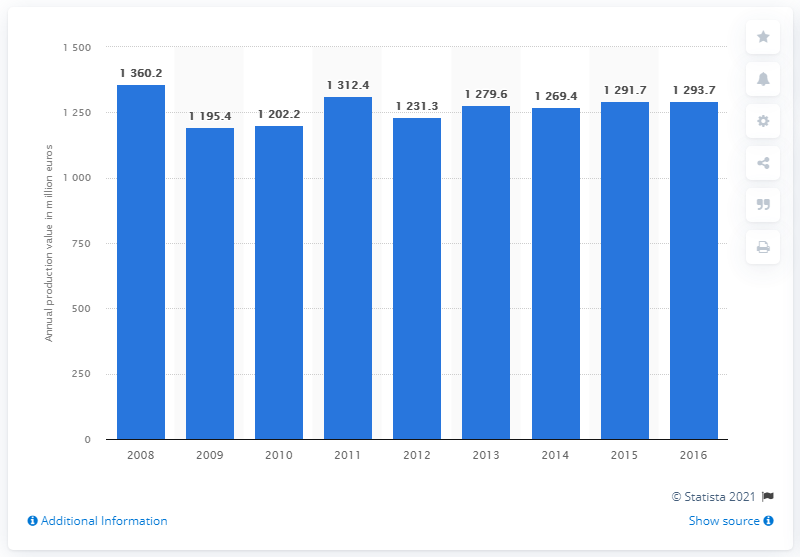Mention a couple of crucial points in this snapshot. In 2016, the production value of paper and paper products in Denmark was approximately 1293.7. 